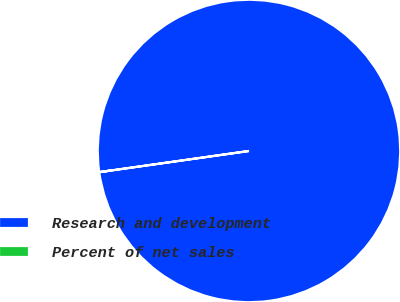Convert chart to OTSL. <chart><loc_0><loc_0><loc_500><loc_500><pie_chart><fcel>Research and development<fcel>Percent of net sales<nl><fcel>99.99%<fcel>0.01%<nl></chart> 